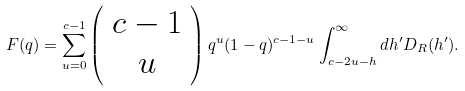Convert formula to latex. <formula><loc_0><loc_0><loc_500><loc_500>F ( q ) = \sum _ { u = 0 } ^ { c - 1 } \left ( \begin{array} { c } c - 1 \\ u \end{array} \right ) q ^ { u } ( 1 - q ) ^ { c - 1 - u } \int _ { c - 2 u - h } ^ { \infty } d h ^ { \prime } D _ { R } ( h ^ { \prime } ) .</formula> 